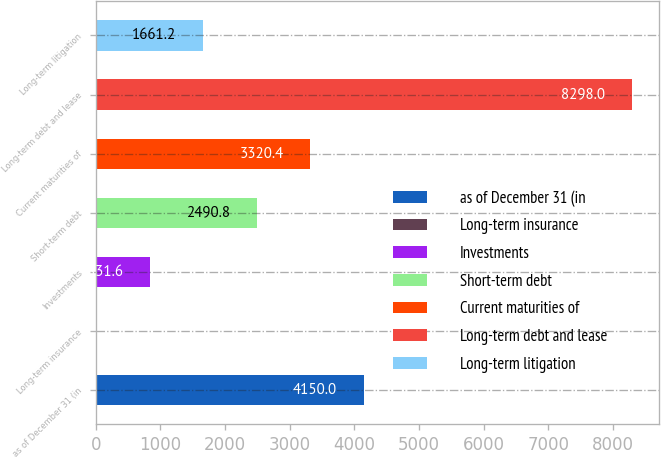<chart> <loc_0><loc_0><loc_500><loc_500><bar_chart><fcel>as of December 31 (in<fcel>Long-term insurance<fcel>Investments<fcel>Short-term debt<fcel>Current maturities of<fcel>Long-term debt and lease<fcel>Long-term litigation<nl><fcel>4150<fcel>2<fcel>831.6<fcel>2490.8<fcel>3320.4<fcel>8298<fcel>1661.2<nl></chart> 